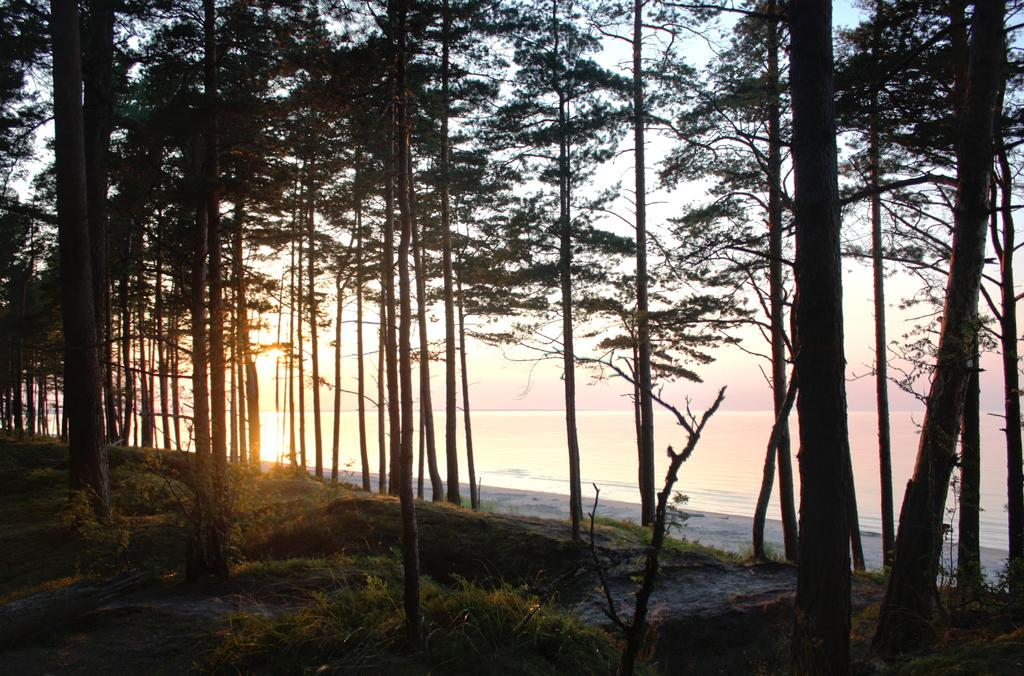What type of vegetation can be seen in the image? There are trees with branches and leaves in the image. What type of ground cover is visible in the image? There is grass visible in the image. What type of natural environment is depicted in the image? The image appears to depict a seashore. What body of water is visible in the image? There is a sea visible in the image. What type of lace can be seen on the vase in the image? There is no vase present in the image, so there is no lace to be seen. 